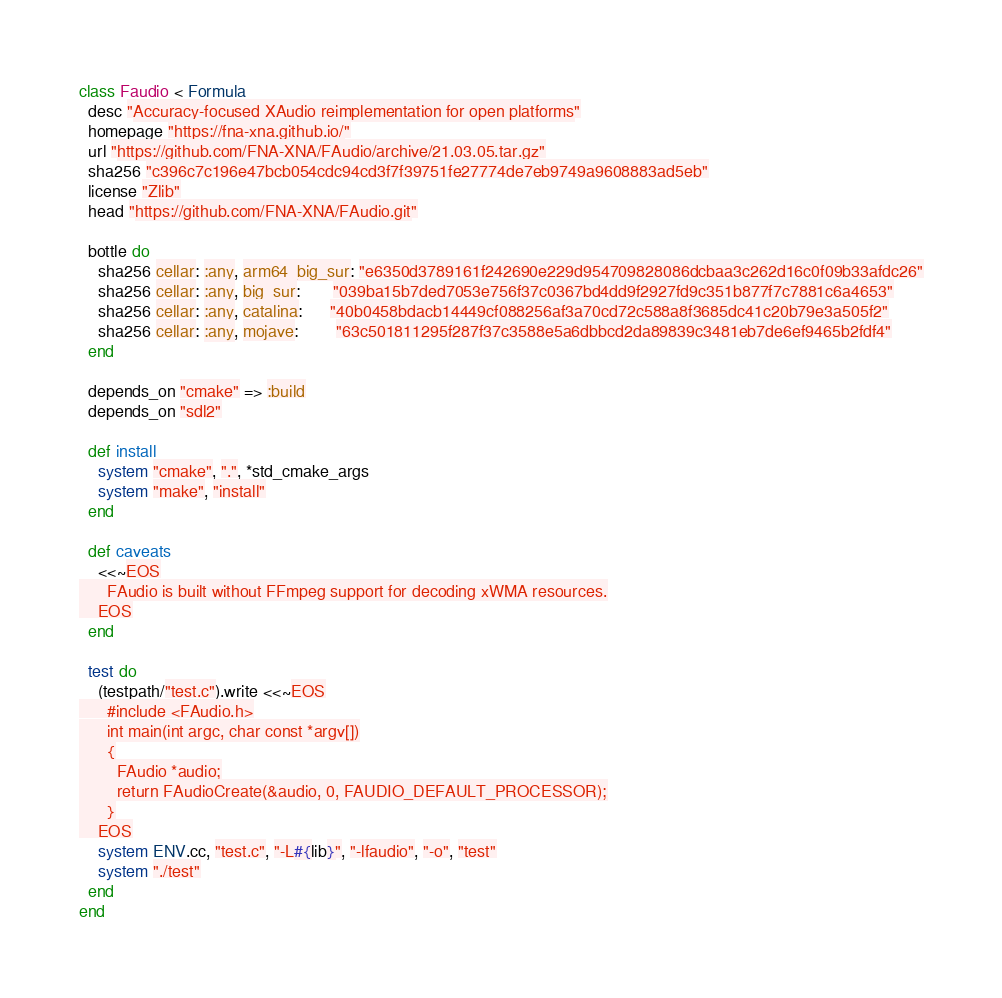Convert code to text. <code><loc_0><loc_0><loc_500><loc_500><_Ruby_>class Faudio < Formula
  desc "Accuracy-focused XAudio reimplementation for open platforms"
  homepage "https://fna-xna.github.io/"
  url "https://github.com/FNA-XNA/FAudio/archive/21.03.05.tar.gz"
  sha256 "c396c7c196e47bcb054cdc94cd3f7f39751fe27774de7eb9749a9608883ad5eb"
  license "Zlib"
  head "https://github.com/FNA-XNA/FAudio.git"

  bottle do
    sha256 cellar: :any, arm64_big_sur: "e6350d3789161f242690e229d954709828086dcbaa3c262d16c0f09b33afdc26"
    sha256 cellar: :any, big_sur:       "039ba15b7ded7053e756f37c0367bd4dd9f2927fd9c351b877f7c7881c6a4653"
    sha256 cellar: :any, catalina:      "40b0458bdacb14449cf088256af3a70cd72c588a8f3685dc41c20b79e3a505f2"
    sha256 cellar: :any, mojave:        "63c501811295f287f37c3588e5a6dbbcd2da89839c3481eb7de6ef9465b2fdf4"
  end

  depends_on "cmake" => :build
  depends_on "sdl2"

  def install
    system "cmake", ".", *std_cmake_args
    system "make", "install"
  end

  def caveats
    <<~EOS
      FAudio is built without FFmpeg support for decoding xWMA resources.
    EOS
  end

  test do
    (testpath/"test.c").write <<~EOS
      #include <FAudio.h>
      int main(int argc, char const *argv[])
      {
        FAudio *audio;
        return FAudioCreate(&audio, 0, FAUDIO_DEFAULT_PROCESSOR);
      }
    EOS
    system ENV.cc, "test.c", "-L#{lib}", "-lfaudio", "-o", "test"
    system "./test"
  end
end
</code> 